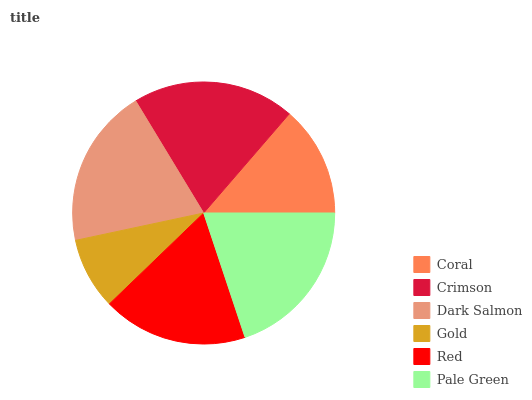Is Gold the minimum?
Answer yes or no. Yes. Is Crimson the maximum?
Answer yes or no. Yes. Is Dark Salmon the minimum?
Answer yes or no. No. Is Dark Salmon the maximum?
Answer yes or no. No. Is Crimson greater than Dark Salmon?
Answer yes or no. Yes. Is Dark Salmon less than Crimson?
Answer yes or no. Yes. Is Dark Salmon greater than Crimson?
Answer yes or no. No. Is Crimson less than Dark Salmon?
Answer yes or no. No. Is Dark Salmon the high median?
Answer yes or no. Yes. Is Red the low median?
Answer yes or no. Yes. Is Pale Green the high median?
Answer yes or no. No. Is Gold the low median?
Answer yes or no. No. 